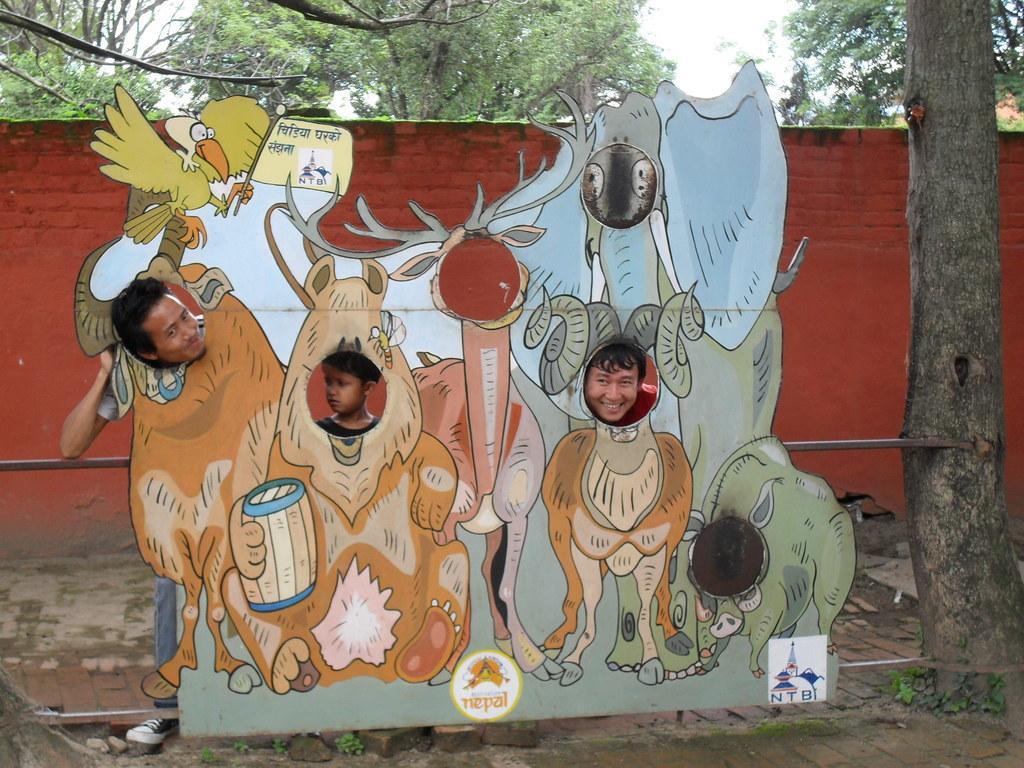Please provide a concise description of this image. In this picture there is a poster in the center of the image, on which there are animals and there are people behind the poster, there is a trunk on the right side of the image and there are trees at the top side of the image. 